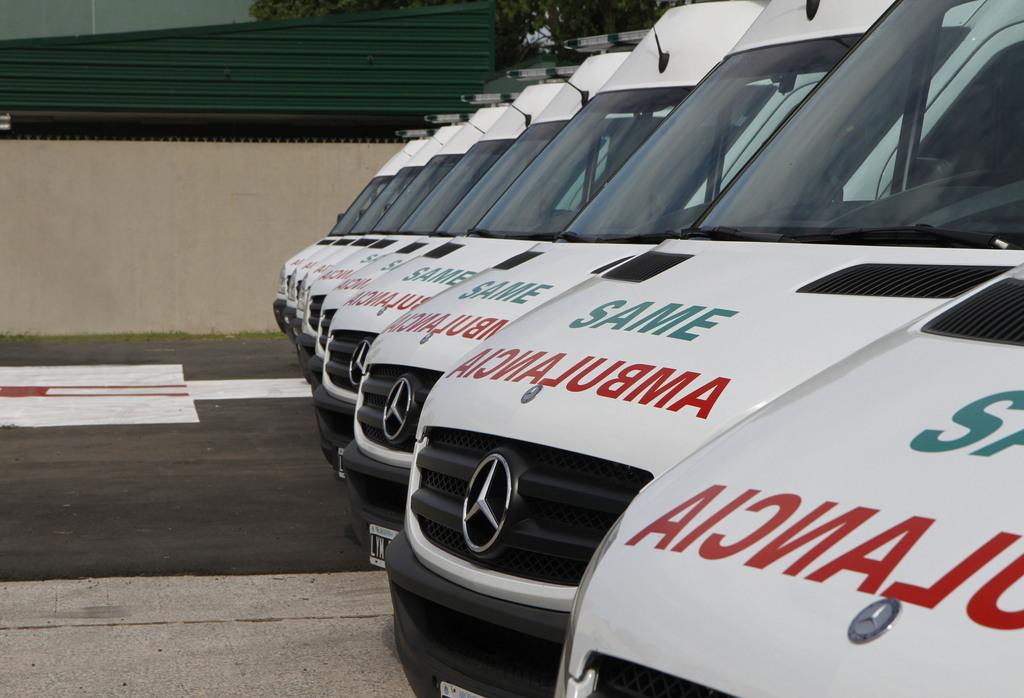What can be seen on the road in the image? There are vehicles on the road in the image. What else is visible in the image besides the vehicles? There are buildings and trees visible in the image. How many eyes can be seen on the trees in the image? Trees do not have eyes, so this question cannot be answered. What type of eggs are being used to decorate the buildings in the image? There are no eggs visible in the image, and they are not being used to decorate the buildings. 